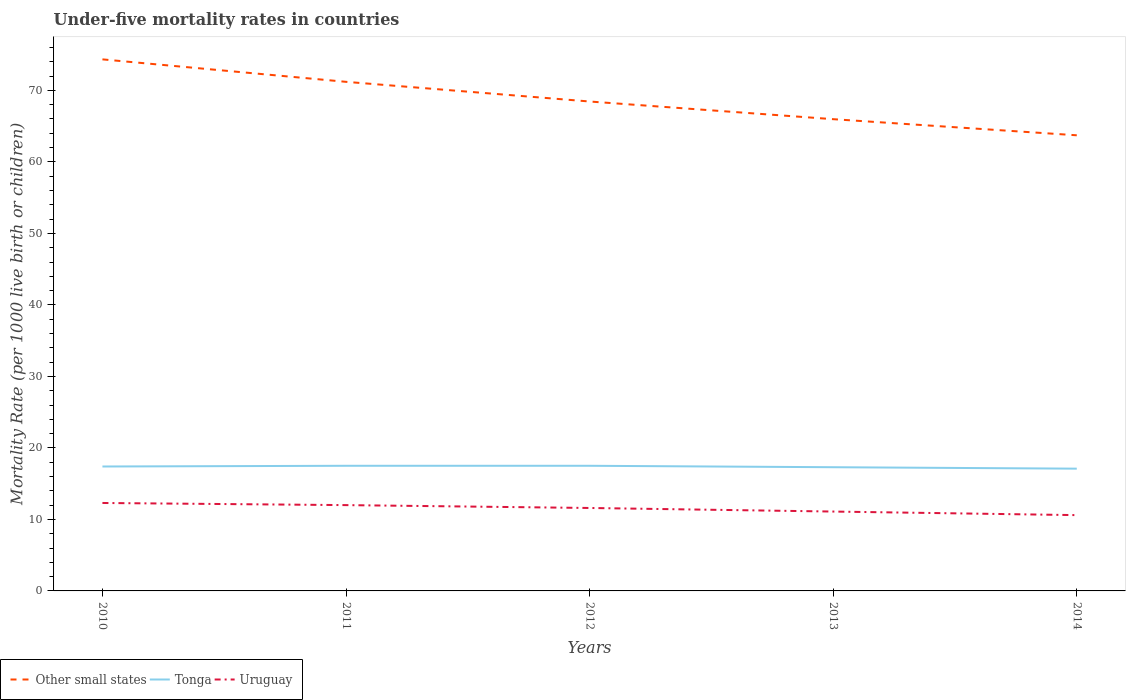Does the line corresponding to Tonga intersect with the line corresponding to Uruguay?
Provide a short and direct response. No. Is the number of lines equal to the number of legend labels?
Make the answer very short. Yes. In which year was the under-five mortality rate in Tonga maximum?
Provide a short and direct response. 2014. What is the total under-five mortality rate in Tonga in the graph?
Your answer should be very brief. 0.2. What is the difference between the highest and the second highest under-five mortality rate in Uruguay?
Your response must be concise. 1.7. What is the difference between the highest and the lowest under-five mortality rate in Tonga?
Your answer should be very brief. 3. Is the under-five mortality rate in Tonga strictly greater than the under-five mortality rate in Other small states over the years?
Keep it short and to the point. Yes. How many years are there in the graph?
Your answer should be compact. 5. What is the difference between two consecutive major ticks on the Y-axis?
Your response must be concise. 10. Does the graph contain any zero values?
Your answer should be very brief. No. Does the graph contain grids?
Provide a succinct answer. No. What is the title of the graph?
Your answer should be very brief. Under-five mortality rates in countries. Does "Armenia" appear as one of the legend labels in the graph?
Ensure brevity in your answer.  No. What is the label or title of the X-axis?
Make the answer very short. Years. What is the label or title of the Y-axis?
Ensure brevity in your answer.  Mortality Rate (per 1000 live birth or children). What is the Mortality Rate (per 1000 live birth or children) of Other small states in 2010?
Give a very brief answer. 74.34. What is the Mortality Rate (per 1000 live birth or children) in Uruguay in 2010?
Keep it short and to the point. 12.3. What is the Mortality Rate (per 1000 live birth or children) in Other small states in 2011?
Offer a very short reply. 71.2. What is the Mortality Rate (per 1000 live birth or children) of Tonga in 2011?
Your response must be concise. 17.5. What is the Mortality Rate (per 1000 live birth or children) of Uruguay in 2011?
Keep it short and to the point. 12. What is the Mortality Rate (per 1000 live birth or children) in Other small states in 2012?
Provide a succinct answer. 68.45. What is the Mortality Rate (per 1000 live birth or children) in Tonga in 2012?
Keep it short and to the point. 17.5. What is the Mortality Rate (per 1000 live birth or children) in Uruguay in 2012?
Your answer should be very brief. 11.6. What is the Mortality Rate (per 1000 live birth or children) of Other small states in 2013?
Provide a short and direct response. 65.97. What is the Mortality Rate (per 1000 live birth or children) of Uruguay in 2013?
Provide a short and direct response. 11.1. What is the Mortality Rate (per 1000 live birth or children) of Other small states in 2014?
Your response must be concise. 63.72. What is the Mortality Rate (per 1000 live birth or children) in Tonga in 2014?
Your answer should be very brief. 17.1. Across all years, what is the maximum Mortality Rate (per 1000 live birth or children) in Other small states?
Ensure brevity in your answer.  74.34. Across all years, what is the maximum Mortality Rate (per 1000 live birth or children) in Uruguay?
Your answer should be compact. 12.3. Across all years, what is the minimum Mortality Rate (per 1000 live birth or children) of Other small states?
Your response must be concise. 63.72. Across all years, what is the minimum Mortality Rate (per 1000 live birth or children) of Tonga?
Provide a short and direct response. 17.1. Across all years, what is the minimum Mortality Rate (per 1000 live birth or children) in Uruguay?
Your answer should be compact. 10.6. What is the total Mortality Rate (per 1000 live birth or children) of Other small states in the graph?
Provide a succinct answer. 343.68. What is the total Mortality Rate (per 1000 live birth or children) in Tonga in the graph?
Make the answer very short. 86.8. What is the total Mortality Rate (per 1000 live birth or children) in Uruguay in the graph?
Your answer should be compact. 57.6. What is the difference between the Mortality Rate (per 1000 live birth or children) of Other small states in 2010 and that in 2011?
Ensure brevity in your answer.  3.14. What is the difference between the Mortality Rate (per 1000 live birth or children) of Uruguay in 2010 and that in 2011?
Your answer should be very brief. 0.3. What is the difference between the Mortality Rate (per 1000 live birth or children) in Other small states in 2010 and that in 2012?
Your response must be concise. 5.89. What is the difference between the Mortality Rate (per 1000 live birth or children) of Tonga in 2010 and that in 2012?
Provide a succinct answer. -0.1. What is the difference between the Mortality Rate (per 1000 live birth or children) in Other small states in 2010 and that in 2013?
Offer a terse response. 8.37. What is the difference between the Mortality Rate (per 1000 live birth or children) in Uruguay in 2010 and that in 2013?
Offer a terse response. 1.2. What is the difference between the Mortality Rate (per 1000 live birth or children) of Other small states in 2010 and that in 2014?
Your answer should be very brief. 10.62. What is the difference between the Mortality Rate (per 1000 live birth or children) in Other small states in 2011 and that in 2012?
Your answer should be very brief. 2.75. What is the difference between the Mortality Rate (per 1000 live birth or children) in Uruguay in 2011 and that in 2012?
Provide a succinct answer. 0.4. What is the difference between the Mortality Rate (per 1000 live birth or children) of Other small states in 2011 and that in 2013?
Your answer should be compact. 5.22. What is the difference between the Mortality Rate (per 1000 live birth or children) of Other small states in 2011 and that in 2014?
Your answer should be compact. 7.48. What is the difference between the Mortality Rate (per 1000 live birth or children) in Other small states in 2012 and that in 2013?
Offer a terse response. 2.47. What is the difference between the Mortality Rate (per 1000 live birth or children) of Other small states in 2012 and that in 2014?
Offer a terse response. 4.73. What is the difference between the Mortality Rate (per 1000 live birth or children) in Uruguay in 2012 and that in 2014?
Offer a very short reply. 1. What is the difference between the Mortality Rate (per 1000 live birth or children) in Other small states in 2013 and that in 2014?
Provide a succinct answer. 2.25. What is the difference between the Mortality Rate (per 1000 live birth or children) in Tonga in 2013 and that in 2014?
Make the answer very short. 0.2. What is the difference between the Mortality Rate (per 1000 live birth or children) in Uruguay in 2013 and that in 2014?
Provide a succinct answer. 0.5. What is the difference between the Mortality Rate (per 1000 live birth or children) in Other small states in 2010 and the Mortality Rate (per 1000 live birth or children) in Tonga in 2011?
Provide a short and direct response. 56.84. What is the difference between the Mortality Rate (per 1000 live birth or children) of Other small states in 2010 and the Mortality Rate (per 1000 live birth or children) of Uruguay in 2011?
Ensure brevity in your answer.  62.34. What is the difference between the Mortality Rate (per 1000 live birth or children) in Tonga in 2010 and the Mortality Rate (per 1000 live birth or children) in Uruguay in 2011?
Offer a very short reply. 5.4. What is the difference between the Mortality Rate (per 1000 live birth or children) in Other small states in 2010 and the Mortality Rate (per 1000 live birth or children) in Tonga in 2012?
Keep it short and to the point. 56.84. What is the difference between the Mortality Rate (per 1000 live birth or children) in Other small states in 2010 and the Mortality Rate (per 1000 live birth or children) in Uruguay in 2012?
Your answer should be very brief. 62.74. What is the difference between the Mortality Rate (per 1000 live birth or children) of Other small states in 2010 and the Mortality Rate (per 1000 live birth or children) of Tonga in 2013?
Offer a terse response. 57.04. What is the difference between the Mortality Rate (per 1000 live birth or children) of Other small states in 2010 and the Mortality Rate (per 1000 live birth or children) of Uruguay in 2013?
Offer a very short reply. 63.24. What is the difference between the Mortality Rate (per 1000 live birth or children) of Tonga in 2010 and the Mortality Rate (per 1000 live birth or children) of Uruguay in 2013?
Ensure brevity in your answer.  6.3. What is the difference between the Mortality Rate (per 1000 live birth or children) of Other small states in 2010 and the Mortality Rate (per 1000 live birth or children) of Tonga in 2014?
Your answer should be compact. 57.24. What is the difference between the Mortality Rate (per 1000 live birth or children) in Other small states in 2010 and the Mortality Rate (per 1000 live birth or children) in Uruguay in 2014?
Provide a short and direct response. 63.74. What is the difference between the Mortality Rate (per 1000 live birth or children) in Other small states in 2011 and the Mortality Rate (per 1000 live birth or children) in Tonga in 2012?
Offer a terse response. 53.7. What is the difference between the Mortality Rate (per 1000 live birth or children) in Other small states in 2011 and the Mortality Rate (per 1000 live birth or children) in Uruguay in 2012?
Keep it short and to the point. 59.6. What is the difference between the Mortality Rate (per 1000 live birth or children) in Other small states in 2011 and the Mortality Rate (per 1000 live birth or children) in Tonga in 2013?
Offer a terse response. 53.9. What is the difference between the Mortality Rate (per 1000 live birth or children) of Other small states in 2011 and the Mortality Rate (per 1000 live birth or children) of Uruguay in 2013?
Keep it short and to the point. 60.1. What is the difference between the Mortality Rate (per 1000 live birth or children) of Tonga in 2011 and the Mortality Rate (per 1000 live birth or children) of Uruguay in 2013?
Offer a very short reply. 6.4. What is the difference between the Mortality Rate (per 1000 live birth or children) in Other small states in 2011 and the Mortality Rate (per 1000 live birth or children) in Tonga in 2014?
Offer a terse response. 54.1. What is the difference between the Mortality Rate (per 1000 live birth or children) of Other small states in 2011 and the Mortality Rate (per 1000 live birth or children) of Uruguay in 2014?
Your answer should be compact. 60.6. What is the difference between the Mortality Rate (per 1000 live birth or children) in Other small states in 2012 and the Mortality Rate (per 1000 live birth or children) in Tonga in 2013?
Provide a succinct answer. 51.15. What is the difference between the Mortality Rate (per 1000 live birth or children) of Other small states in 2012 and the Mortality Rate (per 1000 live birth or children) of Uruguay in 2013?
Your answer should be compact. 57.35. What is the difference between the Mortality Rate (per 1000 live birth or children) of Other small states in 2012 and the Mortality Rate (per 1000 live birth or children) of Tonga in 2014?
Provide a short and direct response. 51.35. What is the difference between the Mortality Rate (per 1000 live birth or children) of Other small states in 2012 and the Mortality Rate (per 1000 live birth or children) of Uruguay in 2014?
Offer a very short reply. 57.85. What is the difference between the Mortality Rate (per 1000 live birth or children) of Other small states in 2013 and the Mortality Rate (per 1000 live birth or children) of Tonga in 2014?
Keep it short and to the point. 48.87. What is the difference between the Mortality Rate (per 1000 live birth or children) of Other small states in 2013 and the Mortality Rate (per 1000 live birth or children) of Uruguay in 2014?
Give a very brief answer. 55.37. What is the difference between the Mortality Rate (per 1000 live birth or children) of Tonga in 2013 and the Mortality Rate (per 1000 live birth or children) of Uruguay in 2014?
Provide a succinct answer. 6.7. What is the average Mortality Rate (per 1000 live birth or children) in Other small states per year?
Make the answer very short. 68.74. What is the average Mortality Rate (per 1000 live birth or children) in Tonga per year?
Provide a succinct answer. 17.36. What is the average Mortality Rate (per 1000 live birth or children) of Uruguay per year?
Provide a succinct answer. 11.52. In the year 2010, what is the difference between the Mortality Rate (per 1000 live birth or children) in Other small states and Mortality Rate (per 1000 live birth or children) in Tonga?
Make the answer very short. 56.94. In the year 2010, what is the difference between the Mortality Rate (per 1000 live birth or children) in Other small states and Mortality Rate (per 1000 live birth or children) in Uruguay?
Give a very brief answer. 62.04. In the year 2011, what is the difference between the Mortality Rate (per 1000 live birth or children) of Other small states and Mortality Rate (per 1000 live birth or children) of Tonga?
Provide a succinct answer. 53.7. In the year 2011, what is the difference between the Mortality Rate (per 1000 live birth or children) in Other small states and Mortality Rate (per 1000 live birth or children) in Uruguay?
Offer a terse response. 59.2. In the year 2012, what is the difference between the Mortality Rate (per 1000 live birth or children) in Other small states and Mortality Rate (per 1000 live birth or children) in Tonga?
Offer a very short reply. 50.95. In the year 2012, what is the difference between the Mortality Rate (per 1000 live birth or children) in Other small states and Mortality Rate (per 1000 live birth or children) in Uruguay?
Provide a succinct answer. 56.85. In the year 2013, what is the difference between the Mortality Rate (per 1000 live birth or children) of Other small states and Mortality Rate (per 1000 live birth or children) of Tonga?
Provide a short and direct response. 48.67. In the year 2013, what is the difference between the Mortality Rate (per 1000 live birth or children) in Other small states and Mortality Rate (per 1000 live birth or children) in Uruguay?
Provide a short and direct response. 54.87. In the year 2013, what is the difference between the Mortality Rate (per 1000 live birth or children) of Tonga and Mortality Rate (per 1000 live birth or children) of Uruguay?
Provide a short and direct response. 6.2. In the year 2014, what is the difference between the Mortality Rate (per 1000 live birth or children) of Other small states and Mortality Rate (per 1000 live birth or children) of Tonga?
Your response must be concise. 46.62. In the year 2014, what is the difference between the Mortality Rate (per 1000 live birth or children) of Other small states and Mortality Rate (per 1000 live birth or children) of Uruguay?
Give a very brief answer. 53.12. In the year 2014, what is the difference between the Mortality Rate (per 1000 live birth or children) of Tonga and Mortality Rate (per 1000 live birth or children) of Uruguay?
Offer a terse response. 6.5. What is the ratio of the Mortality Rate (per 1000 live birth or children) of Other small states in 2010 to that in 2011?
Keep it short and to the point. 1.04. What is the ratio of the Mortality Rate (per 1000 live birth or children) in Tonga in 2010 to that in 2011?
Offer a very short reply. 0.99. What is the ratio of the Mortality Rate (per 1000 live birth or children) of Other small states in 2010 to that in 2012?
Offer a terse response. 1.09. What is the ratio of the Mortality Rate (per 1000 live birth or children) of Tonga in 2010 to that in 2012?
Give a very brief answer. 0.99. What is the ratio of the Mortality Rate (per 1000 live birth or children) of Uruguay in 2010 to that in 2012?
Make the answer very short. 1.06. What is the ratio of the Mortality Rate (per 1000 live birth or children) of Other small states in 2010 to that in 2013?
Offer a very short reply. 1.13. What is the ratio of the Mortality Rate (per 1000 live birth or children) of Uruguay in 2010 to that in 2013?
Your answer should be compact. 1.11. What is the ratio of the Mortality Rate (per 1000 live birth or children) of Other small states in 2010 to that in 2014?
Give a very brief answer. 1.17. What is the ratio of the Mortality Rate (per 1000 live birth or children) in Tonga in 2010 to that in 2014?
Give a very brief answer. 1.02. What is the ratio of the Mortality Rate (per 1000 live birth or children) in Uruguay in 2010 to that in 2014?
Your response must be concise. 1.16. What is the ratio of the Mortality Rate (per 1000 live birth or children) in Other small states in 2011 to that in 2012?
Ensure brevity in your answer.  1.04. What is the ratio of the Mortality Rate (per 1000 live birth or children) of Tonga in 2011 to that in 2012?
Ensure brevity in your answer.  1. What is the ratio of the Mortality Rate (per 1000 live birth or children) of Uruguay in 2011 to that in 2012?
Your answer should be compact. 1.03. What is the ratio of the Mortality Rate (per 1000 live birth or children) in Other small states in 2011 to that in 2013?
Give a very brief answer. 1.08. What is the ratio of the Mortality Rate (per 1000 live birth or children) in Tonga in 2011 to that in 2013?
Your answer should be very brief. 1.01. What is the ratio of the Mortality Rate (per 1000 live birth or children) of Uruguay in 2011 to that in 2013?
Ensure brevity in your answer.  1.08. What is the ratio of the Mortality Rate (per 1000 live birth or children) in Other small states in 2011 to that in 2014?
Ensure brevity in your answer.  1.12. What is the ratio of the Mortality Rate (per 1000 live birth or children) of Tonga in 2011 to that in 2014?
Your answer should be compact. 1.02. What is the ratio of the Mortality Rate (per 1000 live birth or children) in Uruguay in 2011 to that in 2014?
Provide a short and direct response. 1.13. What is the ratio of the Mortality Rate (per 1000 live birth or children) of Other small states in 2012 to that in 2013?
Provide a short and direct response. 1.04. What is the ratio of the Mortality Rate (per 1000 live birth or children) in Tonga in 2012 to that in 2013?
Your response must be concise. 1.01. What is the ratio of the Mortality Rate (per 1000 live birth or children) in Uruguay in 2012 to that in 2013?
Your answer should be very brief. 1.04. What is the ratio of the Mortality Rate (per 1000 live birth or children) in Other small states in 2012 to that in 2014?
Offer a very short reply. 1.07. What is the ratio of the Mortality Rate (per 1000 live birth or children) of Tonga in 2012 to that in 2014?
Ensure brevity in your answer.  1.02. What is the ratio of the Mortality Rate (per 1000 live birth or children) of Uruguay in 2012 to that in 2014?
Make the answer very short. 1.09. What is the ratio of the Mortality Rate (per 1000 live birth or children) of Other small states in 2013 to that in 2014?
Make the answer very short. 1.04. What is the ratio of the Mortality Rate (per 1000 live birth or children) in Tonga in 2013 to that in 2014?
Offer a very short reply. 1.01. What is the ratio of the Mortality Rate (per 1000 live birth or children) in Uruguay in 2013 to that in 2014?
Your answer should be very brief. 1.05. What is the difference between the highest and the second highest Mortality Rate (per 1000 live birth or children) in Other small states?
Your answer should be compact. 3.14. What is the difference between the highest and the lowest Mortality Rate (per 1000 live birth or children) in Other small states?
Make the answer very short. 10.62. 